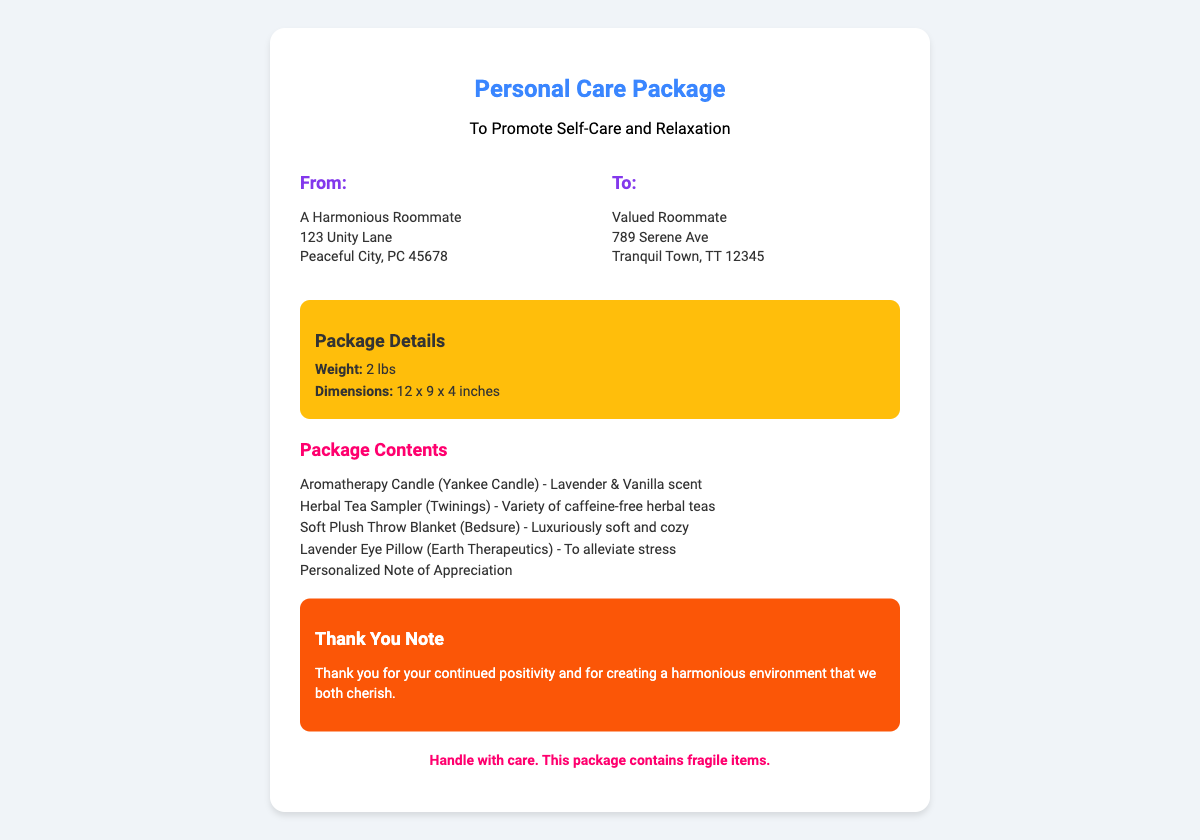What is the title of the package? The title of the package is displayed prominently at the top of the document, highlighting its purpose.
Answer: Personal Care Package Who is the sender of the package? The sender's name and address are located in the "From" section of the document.
Answer: A Harmonious Roommate What is the recipient's address? The recipient's address is in the "To" section and includes their name and location.
Answer: Valued Roommate, 789 Serene Ave, Tranquil Town, TT 12345 What is the total weight of the package? The weight of the package is specified in the package details section.
Answer: 2 lbs What are the dimensions of the package? The dimensions are provided in the package details section and indicate the size of the package.
Answer: 12 x 9 x 4 inches What item is included for stress relief? One of the items included aims specifically to help alleviate stress.
Answer: Lavender Eye Pillow How many different types of tea are offered in the package? The package contents mention a sampler that includes multiple varieties.
Answer: Variety of caffeine-free herbal teas What is the purpose of the note included in the package? The note expresses appreciation and highlights the positive impact of the recipient.
Answer: Thank you for your continued positivity What should you do with the package? There is a cautionary statement regarding the handling of the package.
Answer: Handle with care 